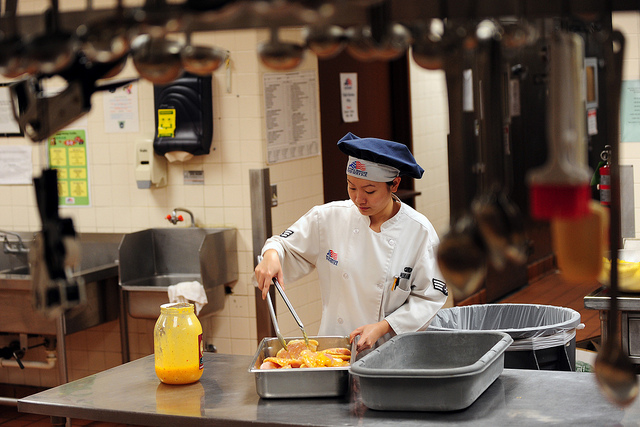Create a detailed, fantastical story about the chef in this image. In an enchanted realm where culinary magic reigns, Chef Elara is a renowned sorcerer whose dishes bring joy and wonder. Today's task is no ordinary meal; she is preparing the legendary Citrus Elixir, known for its ability to grant temporary invisibility. Each ingredient must be handled with care and precision. The large kitchen is filled with magical implements: floating ladles that stir on command, enchanted knives that chop with dexterity, and a colossal cauldron simmering with the essence of sunlight. As Elara blends the citrus fruits, she chants ancient incantations, imbuing the elixir with powerful enchantments. The golden liquid glows with an otherworldly brilliance, and as she pours it into a crystal decanter, a warm, ethereal light fills the room. The elixir is now ready, but Elara knows that with great power comes great responsibility. She secures the potion in a guarded vault, awaiting the moment when its magic will be needed to safeguard the kingdom from unseen threats. 